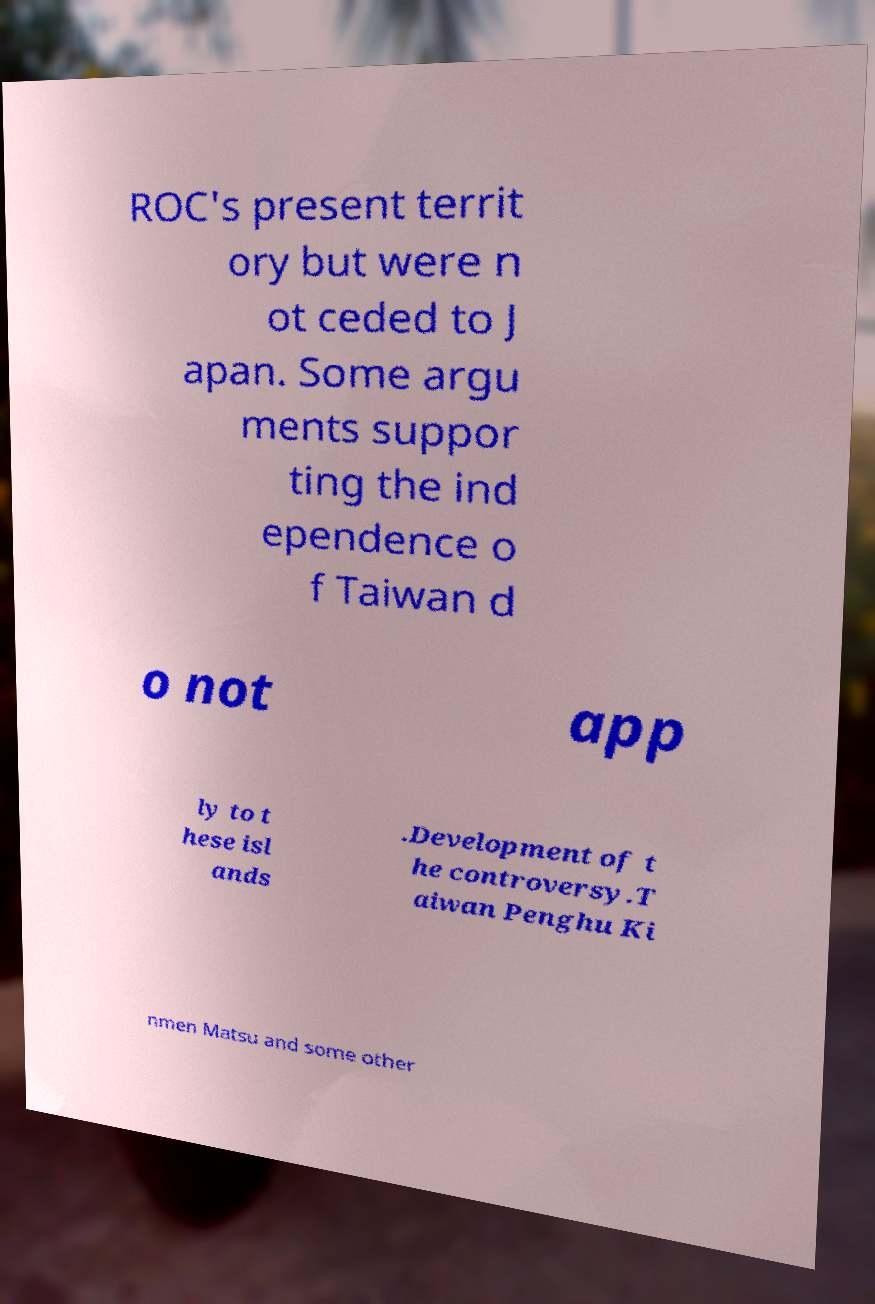Can you read and provide the text displayed in the image?This photo seems to have some interesting text. Can you extract and type it out for me? ROC's present territ ory but were n ot ceded to J apan. Some argu ments suppor ting the ind ependence o f Taiwan d o not app ly to t hese isl ands .Development of t he controversy.T aiwan Penghu Ki nmen Matsu and some other 